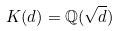<formula> <loc_0><loc_0><loc_500><loc_500>K ( d ) = \mathbb { Q } ( \sqrt { d } )</formula> 